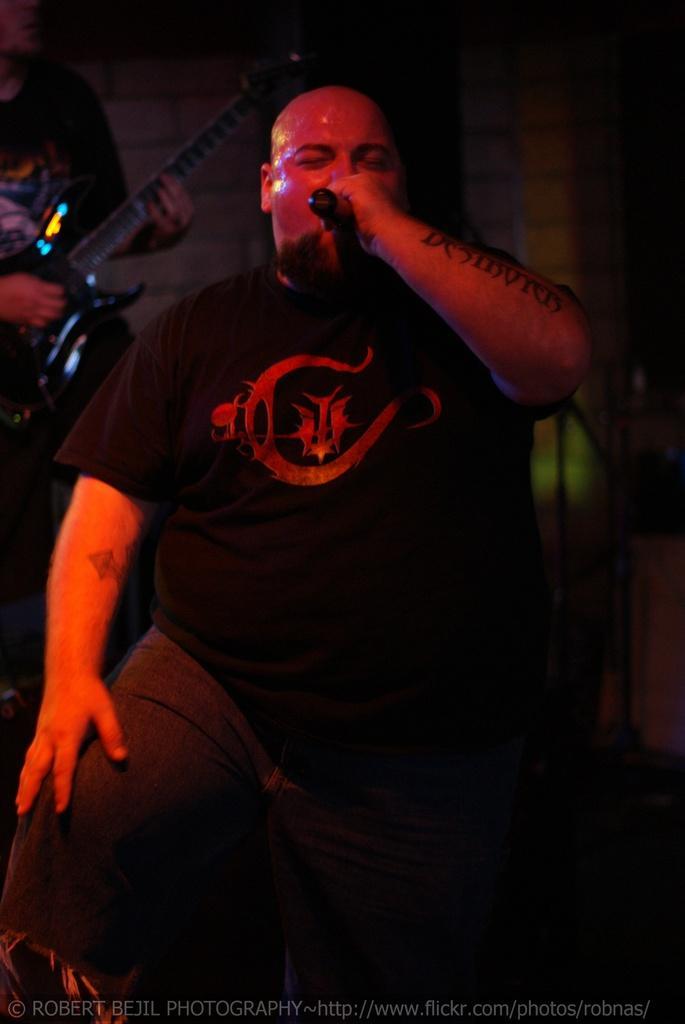Can you describe this image briefly? In the picture we can see a man standing and singing a song in the microphone holding it and he is in a black T-shirt and bald head and behind him we can see a person standing and playing the musical instrument. 